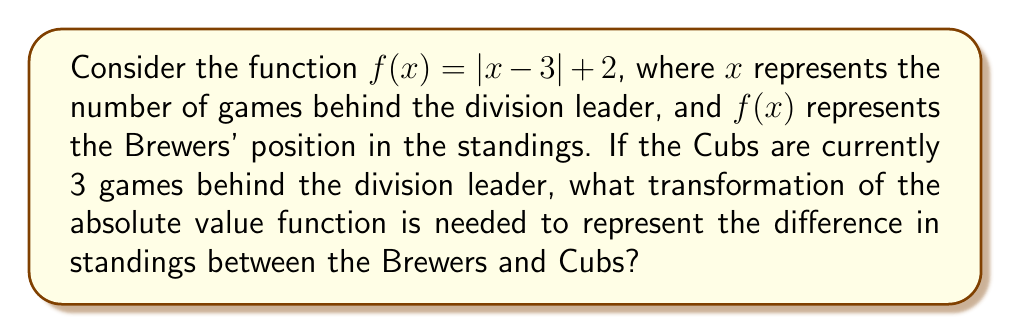Teach me how to tackle this problem. Let's approach this step-by-step:

1) The general form of an absolute value function is $f(x) = |x|$.

2) In our given function $f(x) = |x - 3| + 2$, we can identify two transformations:
   a) A horizontal shift of 3 units right: $|x - 3|$
   b) A vertical shift of 2 units up: $|x - 3| + 2$

3) The Cubs are 3 games behind the division leader, which corresponds to the vertex of the absolute value function $(3, 2)$.

4) To find the difference in standings, we need to subtract the Cubs' position (which is always 3) from the Brewers' position:

   $g(x) = f(x) - 3 = |x - 3| + 2 - 3 = |x - 3| - 1$

5) This new function $g(x) = |x - 3| - 1$ represents the difference in standings between the Brewers and Cubs.

6) Comparing $g(x)$ to the original absolute value function $f(x) = |x|$, we can identify the following transformations:
   a) A horizontal shift of 3 units right: $|x - 3|$
   b) A vertical shift of 1 unit down: $|x - 3| - 1$

7) The vertical shift of 1 unit down is the transformation that represents the difference in standings between the Brewers and Cubs.
Answer: Vertical shift 1 unit down 